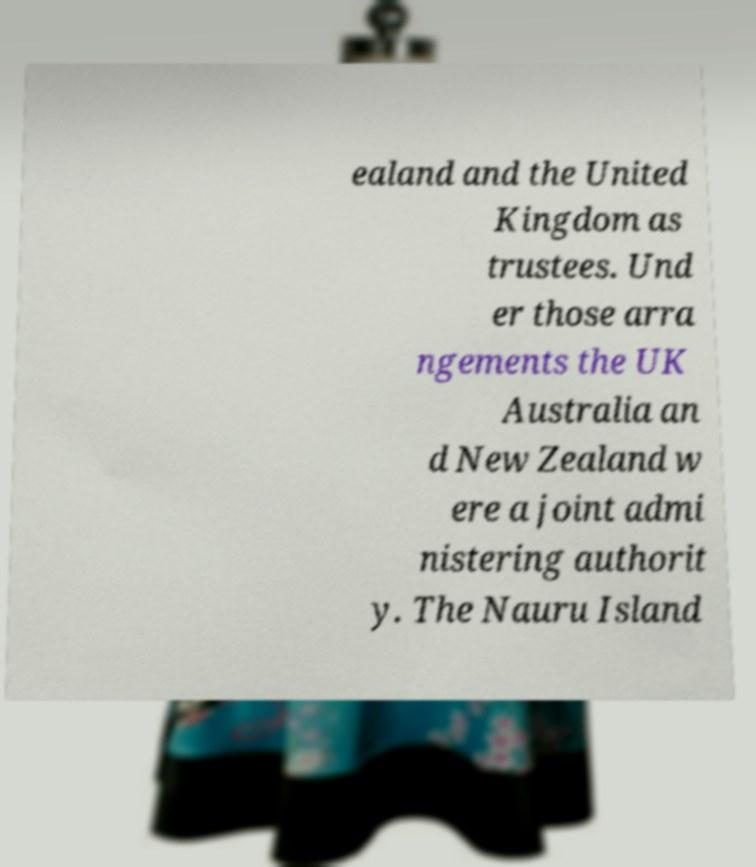Could you extract and type out the text from this image? ealand and the United Kingdom as trustees. Und er those arra ngements the UK Australia an d New Zealand w ere a joint admi nistering authorit y. The Nauru Island 